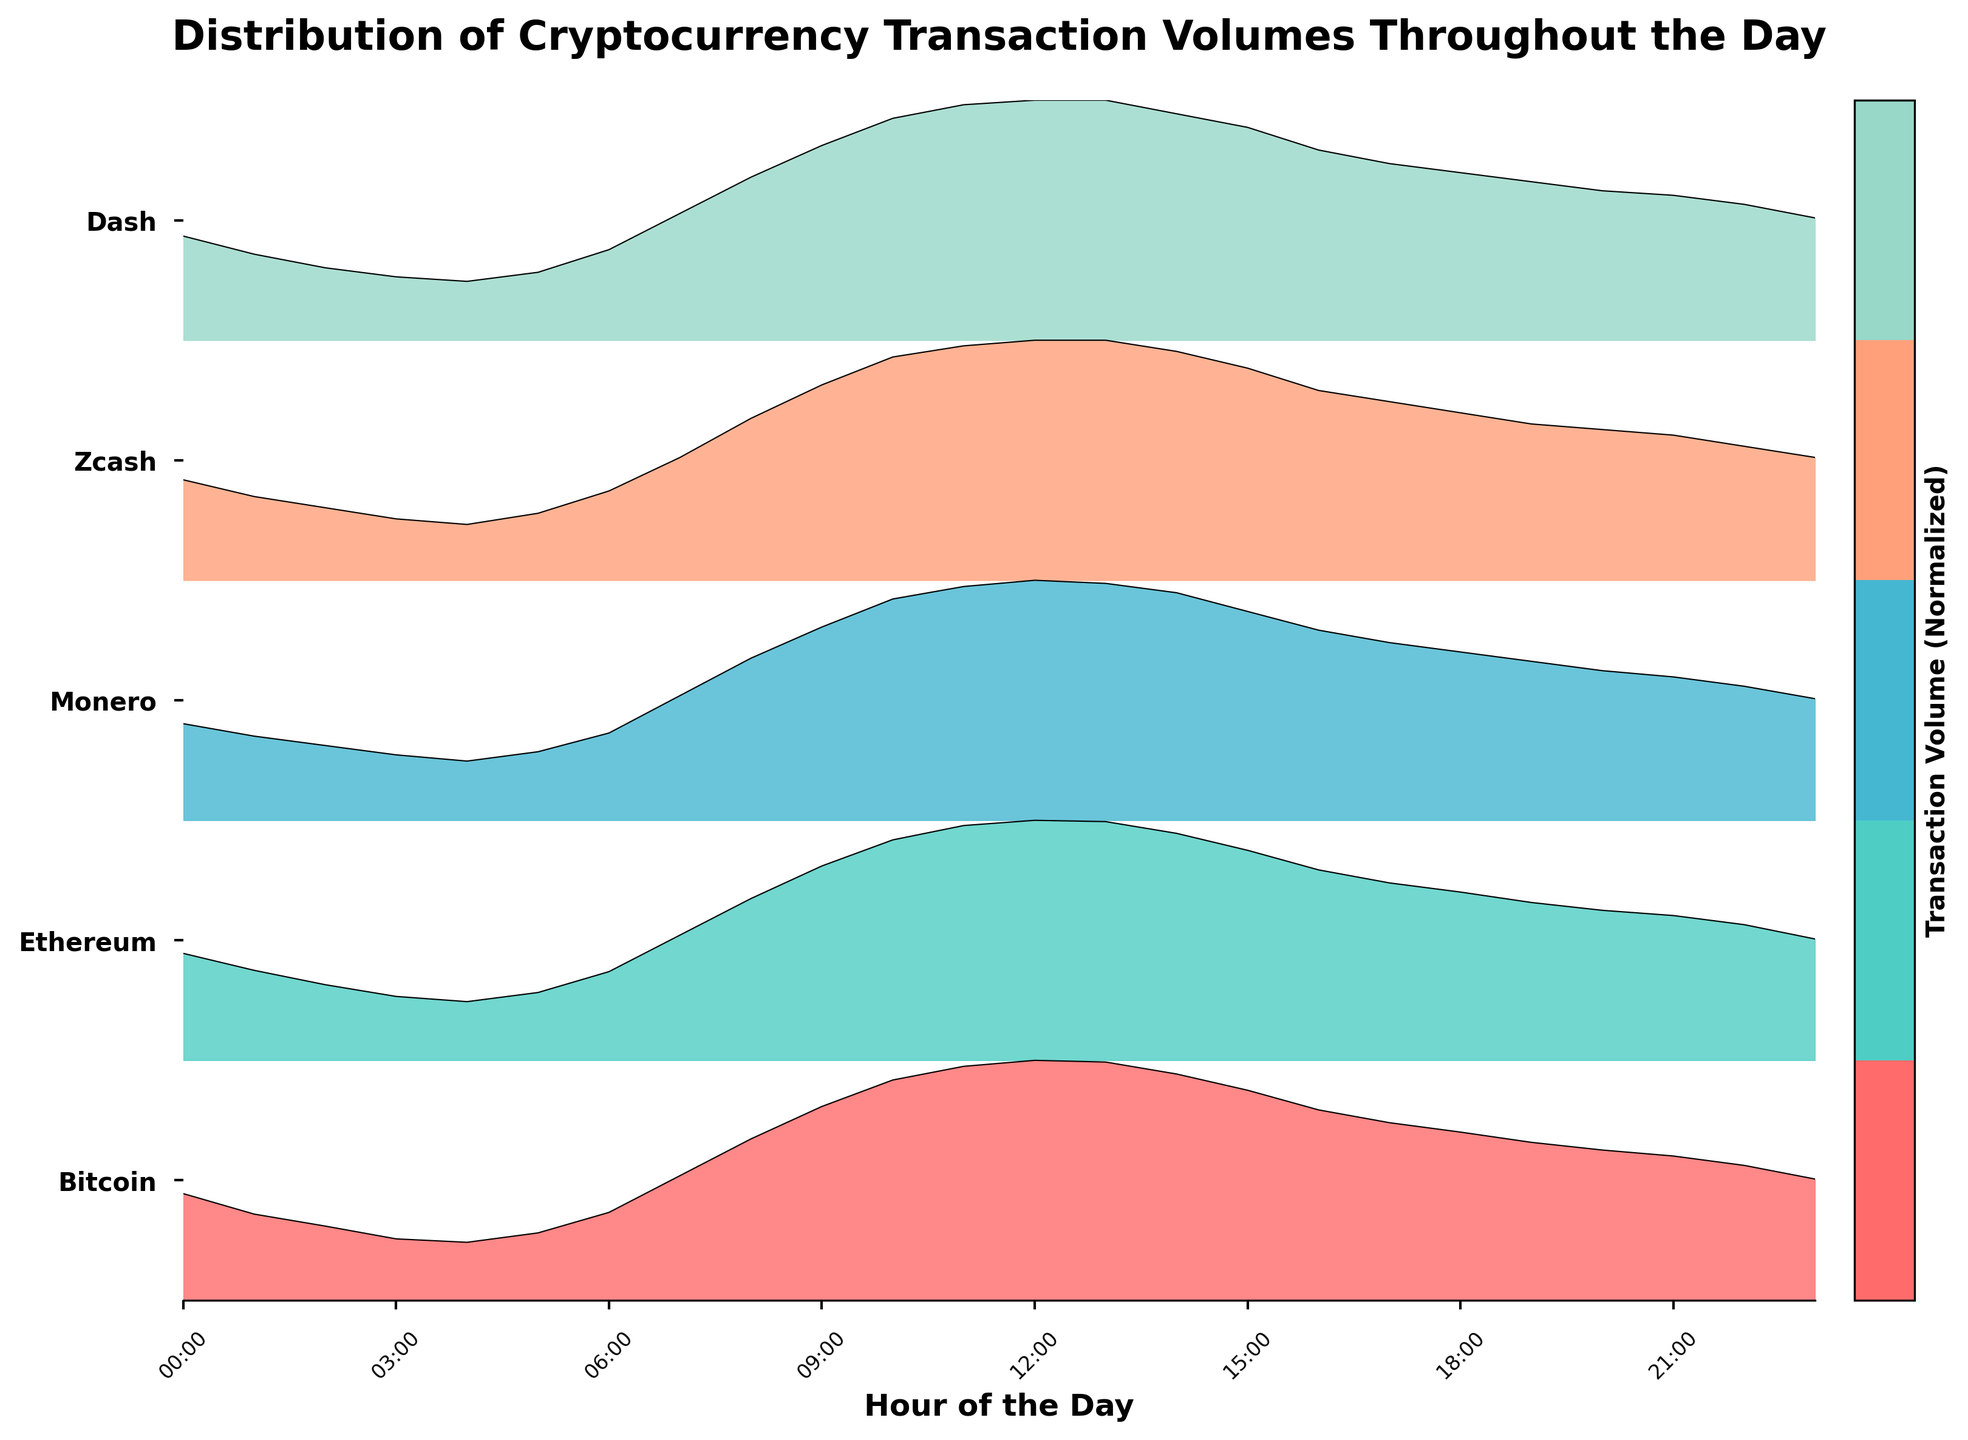What is the title of the figure? The title of the figure is displayed at the top and consists of text. By referring to the title area above the plot, we can directly read it.
Answer: Distribution of Cryptocurrency Transaction Volumes Throughout the Day How many different cryptocurrencies are depicted in the plot? Observe the y-axis labels on the right side of the plot. Each label corresponds to one cryptocurrency. Count the number of unique labels.
Answer: 5 Which cryptocurrency has the highest volume at 12:00? Find the 12:00 (or close) on the x-axis, and look for the highest peak among the ridgelines. The corresponding y-axis label will indicate the cryptocurrency.
Answer: Bitcoin At what hour does Ethereum's transaction volume peak? Identify the ridgeline corresponding to Ethereum, then trace its highest peak to the corresponding hour on the x-axis.
Answer: 12:00 Compare the transaction volumes of Bitcoin and Dash at 18:00. Which cryptocurrency has a higher volume? Locate 18:00 on the x-axis and compare the heights of Bitcoin's and Dash's ridgelines. The taller peak indicates the cryptocurrency with the higher volume.
Answer: Bitcoin What observable trend can be seen in the transaction volume of Monero throughout the day? Follow Monero's ridgeline from left to right. Notice whether it rises, falls, peaks, or has specific patterns corresponding to different hours.
Answer: Rises to a peak around 12:00, then gradually decreases How does Zcash's transaction volume at 00:00 compare to 23:00? Locate the ridgeline for Zcash at 00:00 and 23:00 on the x-axis and compare their heights. The difference in height determines the comparison.
Answer: Higher at 00:00 Which cryptocurrency has the least fluctuation in transaction volume throughout the day? Examine all ridgelines and observe which has the least variation in height from hour to hour. The one with the most stable height reflects the least fluctuation.
Answer: Dash During what hours are Bitcoin's transaction volumes higher than 20 units? Identify the ridgeline of Bitcoin and locate the points where it crosses the 20-unit mark on the y-axis. Note the corresponding hours on the x-axis.
Answer: 9:00 to 15:00 How does the shape of Dash's transaction volume distribution compare to Bitcoin's? Compare the overall shape and pattern of the ridgeline for Dash with Bitcoin. Notice differences such as peaks, troughs, and general trends.
Answer: More stable, fewer peaks 